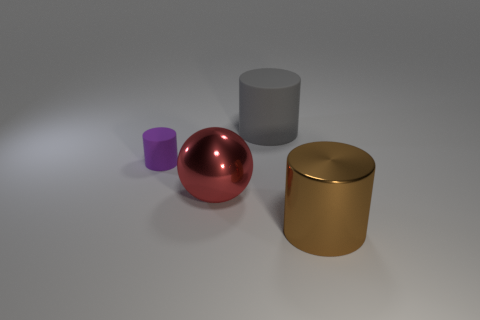Subtract all purple cylinders. Subtract all red blocks. How many cylinders are left? 2 Add 4 purple rubber cylinders. How many objects exist? 8 Subtract all cylinders. How many objects are left? 1 Subtract all big gray things. Subtract all large shiny cylinders. How many objects are left? 2 Add 2 red metal spheres. How many red metal spheres are left? 3 Add 4 large metallic cylinders. How many large metallic cylinders exist? 5 Subtract 1 purple cylinders. How many objects are left? 3 